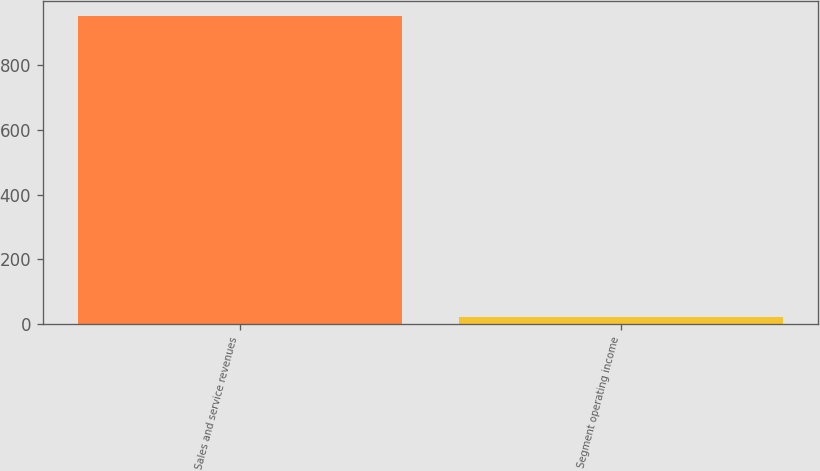Convert chart to OTSL. <chart><loc_0><loc_0><loc_500><loc_500><bar_chart><fcel>Sales and service revenues<fcel>Segment operating income<nl><fcel>952<fcel>21<nl></chart> 